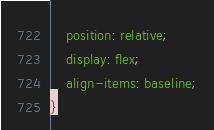Convert code to text. <code><loc_0><loc_0><loc_500><loc_500><_CSS_>    position: relative;
    display: flex;
    align-items: baseline;
}
</code> 